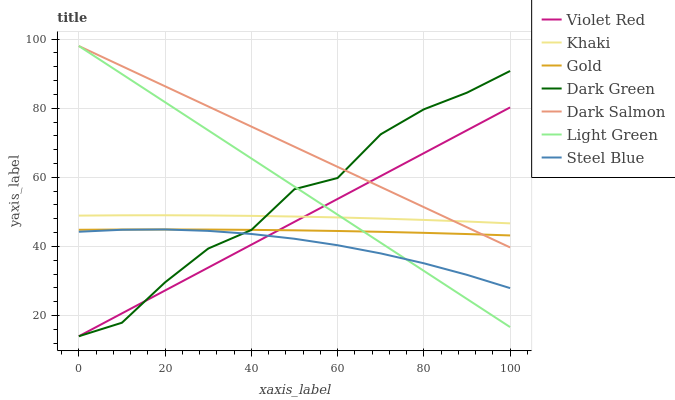Does Steel Blue have the minimum area under the curve?
Answer yes or no. Yes. Does Dark Salmon have the maximum area under the curve?
Answer yes or no. Yes. Does Khaki have the minimum area under the curve?
Answer yes or no. No. Does Khaki have the maximum area under the curve?
Answer yes or no. No. Is Violet Red the smoothest?
Answer yes or no. Yes. Is Dark Green the roughest?
Answer yes or no. Yes. Is Khaki the smoothest?
Answer yes or no. No. Is Khaki the roughest?
Answer yes or no. No. Does Violet Red have the lowest value?
Answer yes or no. Yes. Does Gold have the lowest value?
Answer yes or no. No. Does Light Green have the highest value?
Answer yes or no. Yes. Does Khaki have the highest value?
Answer yes or no. No. Is Gold less than Khaki?
Answer yes or no. Yes. Is Khaki greater than Steel Blue?
Answer yes or no. Yes. Does Dark Salmon intersect Violet Red?
Answer yes or no. Yes. Is Dark Salmon less than Violet Red?
Answer yes or no. No. Is Dark Salmon greater than Violet Red?
Answer yes or no. No. Does Gold intersect Khaki?
Answer yes or no. No. 